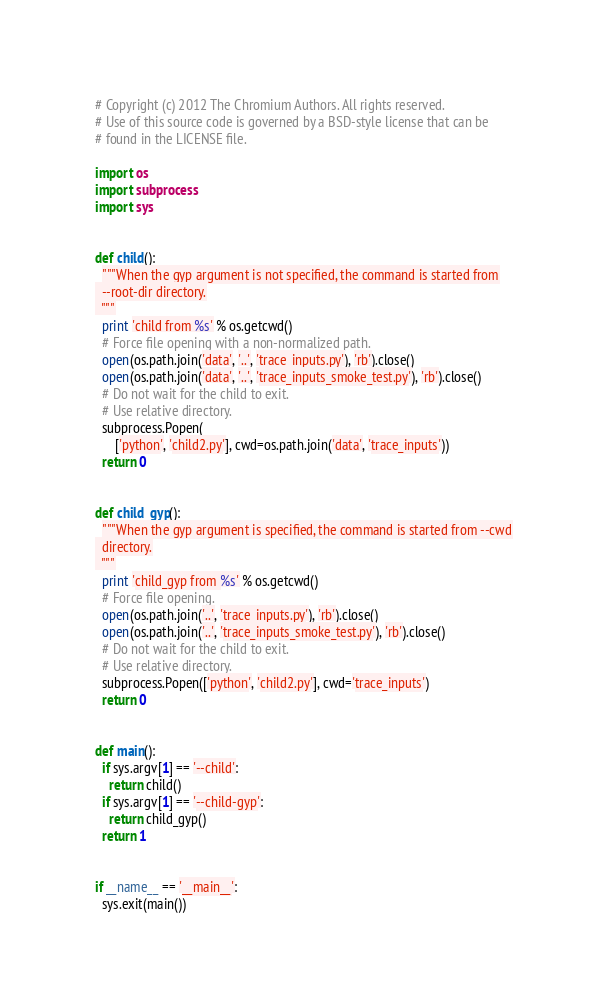<code> <loc_0><loc_0><loc_500><loc_500><_Python_># Copyright (c) 2012 The Chromium Authors. All rights reserved.
# Use of this source code is governed by a BSD-style license that can be
# found in the LICENSE file.

import os
import subprocess
import sys


def child():
  """When the gyp argument is not specified, the command is started from
  --root-dir directory.
  """
  print 'child from %s' % os.getcwd()
  # Force file opening with a non-normalized path.
  open(os.path.join('data', '..', 'trace_inputs.py'), 'rb').close()
  open(os.path.join('data', '..', 'trace_inputs_smoke_test.py'), 'rb').close()
  # Do not wait for the child to exit.
  # Use relative directory.
  subprocess.Popen(
      ['python', 'child2.py'], cwd=os.path.join('data', 'trace_inputs'))
  return 0


def child_gyp():
  """When the gyp argument is specified, the command is started from --cwd
  directory.
  """
  print 'child_gyp from %s' % os.getcwd()
  # Force file opening.
  open(os.path.join('..', 'trace_inputs.py'), 'rb').close()
  open(os.path.join('..', 'trace_inputs_smoke_test.py'), 'rb').close()
  # Do not wait for the child to exit.
  # Use relative directory.
  subprocess.Popen(['python', 'child2.py'], cwd='trace_inputs')
  return 0


def main():
  if sys.argv[1] == '--child':
    return child()
  if sys.argv[1] == '--child-gyp':
    return child_gyp()
  return 1


if __name__ == '__main__':
  sys.exit(main())
</code> 